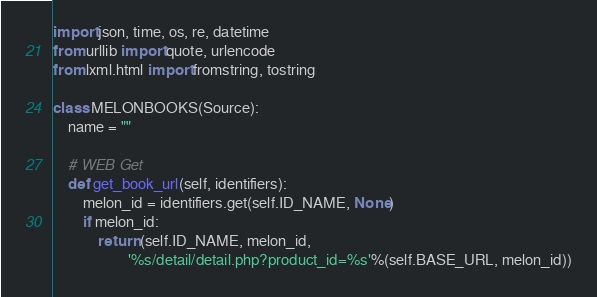Convert code to text. <code><loc_0><loc_0><loc_500><loc_500><_Python_>
import json, time, os, re, datetime
from urllib import quote, urlencode
from lxml.html import fromstring, tostring

class MELONBOOKS(Source):
    name = ""

    # WEB Get
    def get_book_url(self, identifiers):
        melon_id = identifiers.get(self.ID_NAME, None)
        if melon_id:
            return (self.ID_NAME, melon_id,
                    '%s/detail/detail.php?product_id=%s'%(self.BASE_URL, melon_id))
</code> 